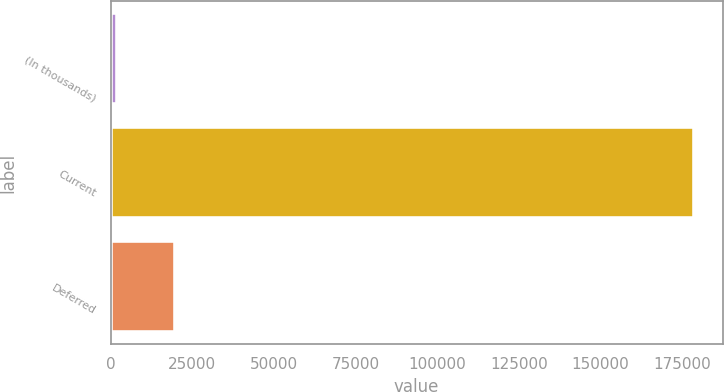<chart> <loc_0><loc_0><loc_500><loc_500><bar_chart><fcel>(In thousands)<fcel>Current<fcel>Deferred<nl><fcel>2014<fcel>178450<fcel>19657.6<nl></chart> 